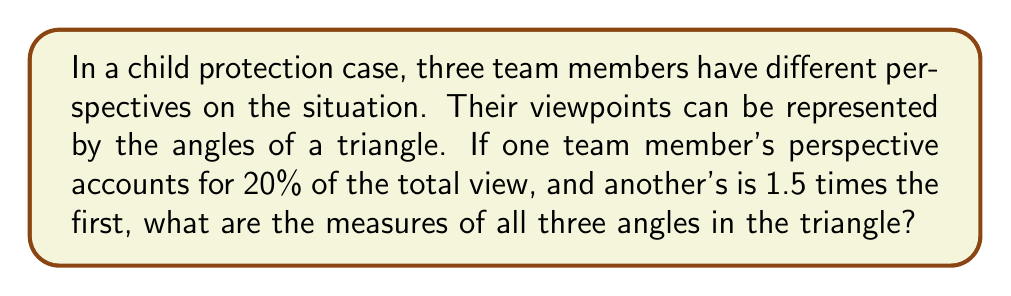Solve this math problem. Let's approach this step-by-step:

1) First, recall that the sum of angles in a triangle is always 180°.

2) Let's assign variables to our angles:
   $a$ = the first perspective (20% of the total)
   $b$ = the second perspective (1.5 times the first)
   $c$ = the third perspective (the remaining angle)

3) We can set up our first equation:
   $a + b + c = 180°$

4) We know that $a$ is 20% of 180°:
   $a = 0.20 \times 180° = 36°$

5) We're told that $b$ is 1.5 times $a$:
   $b = 1.5a = 1.5 \times 36° = 54°$

6) Now we can solve for $c$ using our original equation:
   $c = 180° - a - b = 180° - 36° - 54° = 90°$

7) Let's verify:
   $36° + 54° + 90° = 180°$

Thus, we have found all three angles of our triangle.

[asy]
unitsize(2cm);
pair A = (0,0), B = (2,0), C = (1,1.732);
draw(A--B--C--A);
label("36°", A, SW);
label("54°", B, SE);
label("90°", C, N);
[/asy]

This triangle represents the three perspectives in the case, with each angle symbolizing the weight or significance of each team member's viewpoint.
Answer: $36°$, $54°$, $90°$ 